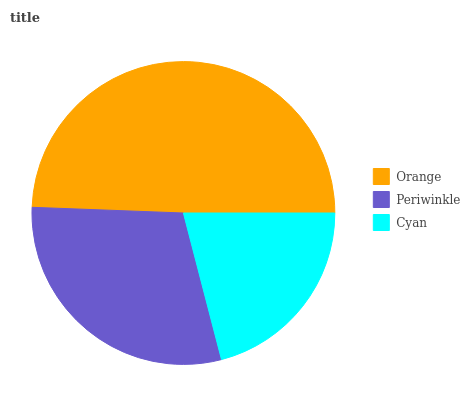Is Cyan the minimum?
Answer yes or no. Yes. Is Orange the maximum?
Answer yes or no. Yes. Is Periwinkle the minimum?
Answer yes or no. No. Is Periwinkle the maximum?
Answer yes or no. No. Is Orange greater than Periwinkle?
Answer yes or no. Yes. Is Periwinkle less than Orange?
Answer yes or no. Yes. Is Periwinkle greater than Orange?
Answer yes or no. No. Is Orange less than Periwinkle?
Answer yes or no. No. Is Periwinkle the high median?
Answer yes or no. Yes. Is Periwinkle the low median?
Answer yes or no. Yes. Is Orange the high median?
Answer yes or no. No. Is Cyan the low median?
Answer yes or no. No. 